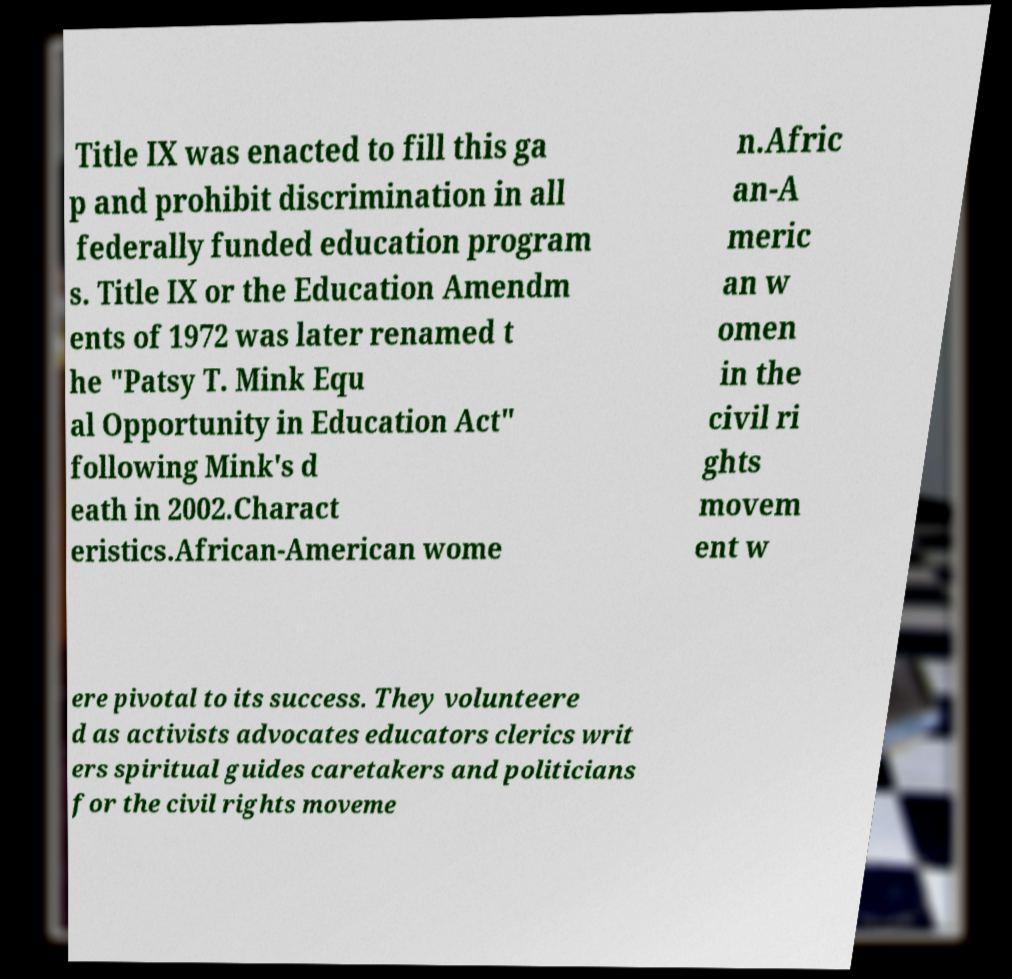What messages or text are displayed in this image? I need them in a readable, typed format. Title IX was enacted to fill this ga p and prohibit discrimination in all federally funded education program s. Title IX or the Education Amendm ents of 1972 was later renamed t he "Patsy T. Mink Equ al Opportunity in Education Act" following Mink's d eath in 2002.Charact eristics.African-American wome n.Afric an-A meric an w omen in the civil ri ghts movem ent w ere pivotal to its success. They volunteere d as activists advocates educators clerics writ ers spiritual guides caretakers and politicians for the civil rights moveme 